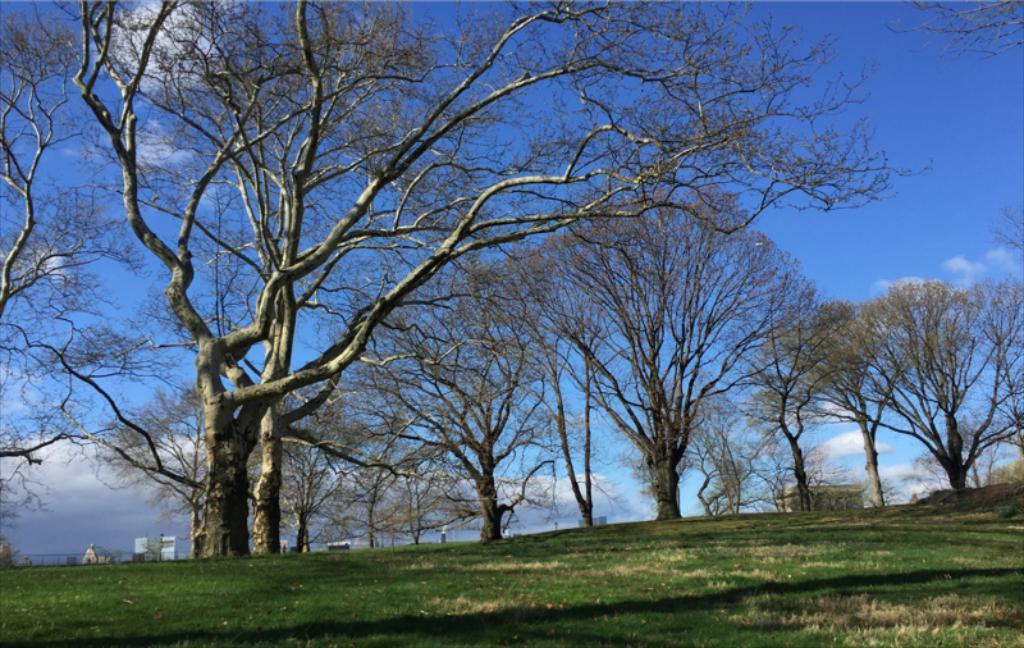In one or two sentences, can you explain what this image depicts? In this image, there are a few trees, buildings. We can see the fence and the ground with grass and some objects. We can also see the sky with clouds. 